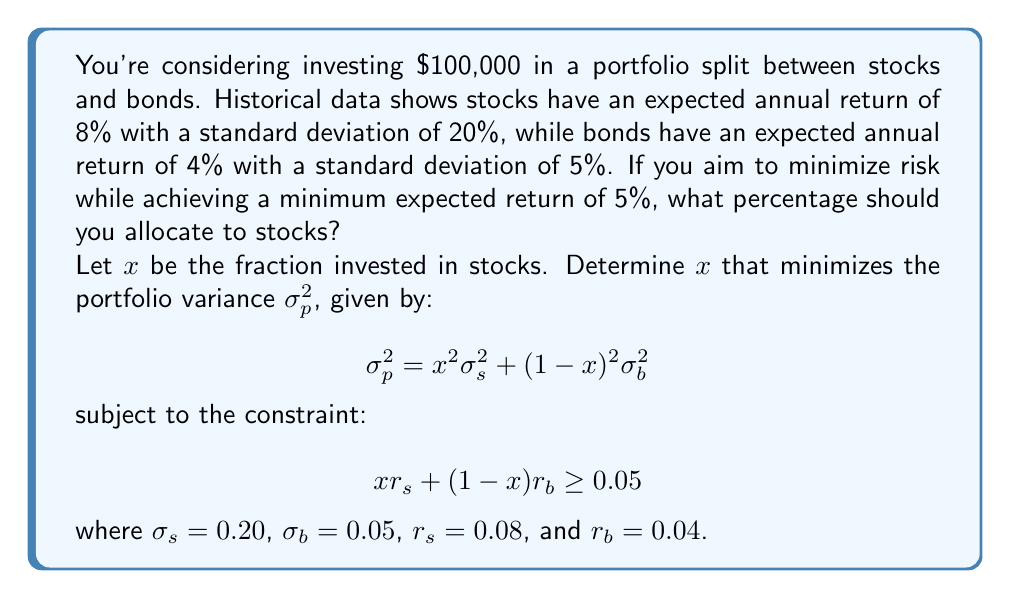Show me your answer to this math problem. 1) First, let's set up the constraint equation:
   $0.08x + 0.04(1-x) \geq 0.05$
   $0.08x + 0.04 - 0.04x \geq 0.05$
   $0.04x \geq 0.01$
   $x \geq 0.25$

2) Now, we need to minimize the portfolio variance:
   $\sigma_p^2 = x^2(0.20)^2 + (1-x)^2(0.05)^2$
   $\sigma_p^2 = 0.04x^2 + 0.0025(1-2x+x^2)$
   $\sigma_p^2 = 0.04x^2 + 0.0025 - 0.005x + 0.0025x^2$
   $\sigma_p^2 = 0.0425x^2 - 0.005x + 0.0025$

3) To find the minimum, we differentiate and set to zero:
   $\frac{d\sigma_p^2}{dx} = 0.085x - 0.005 = 0$
   $0.085x = 0.005$
   $x = \frac{0.005}{0.085} \approx 0.0588$

4) However, this solution doesn't meet our constraint of $x \geq 0.25$. 
   Since the function is quadratic (opens upward), the minimum value 
   that satisfies our constraint is at $x = 0.25$.

5) To verify, let's check the portfolio return:
   $0.08(0.25) + 0.04(0.75) = 0.02 + 0.03 = 0.05$

   This meets our minimum return requirement of 5%.
Answer: 25% in stocks, 75% in bonds 